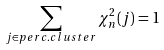<formula> <loc_0><loc_0><loc_500><loc_500>\sum _ { j \in p e r c . c l u s t e r } \chi _ { n } ^ { 2 } ( j ) = 1</formula> 